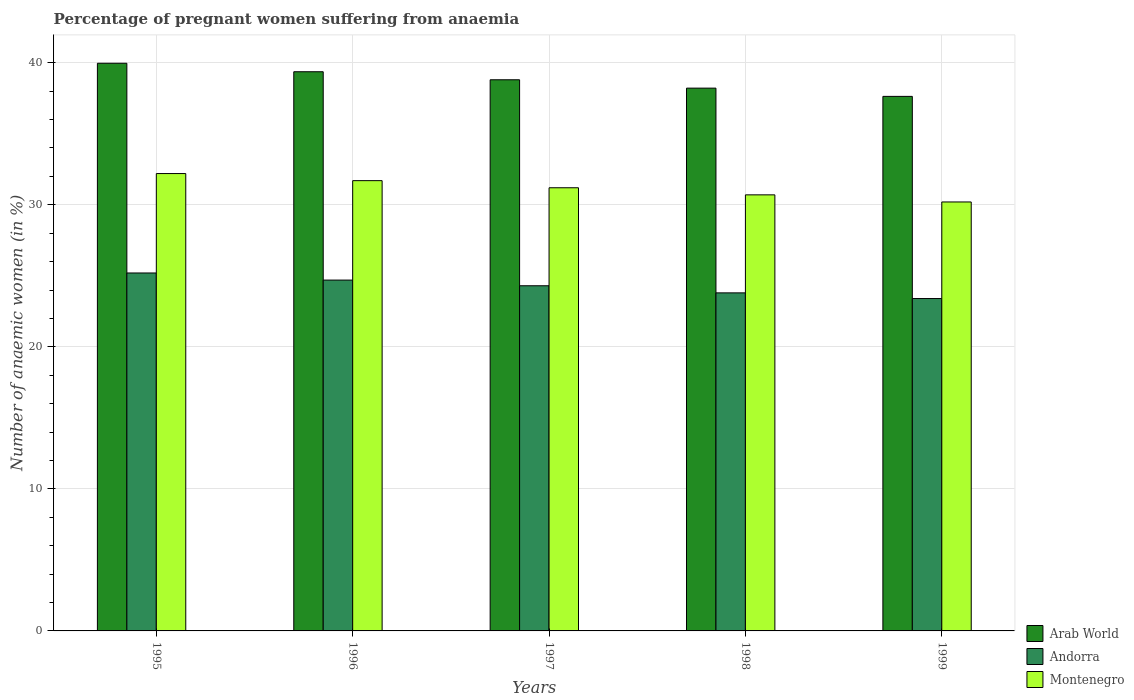How many different coloured bars are there?
Your response must be concise. 3. How many bars are there on the 4th tick from the left?
Your answer should be very brief. 3. What is the label of the 5th group of bars from the left?
Your response must be concise. 1999. In how many cases, is the number of bars for a given year not equal to the number of legend labels?
Your answer should be very brief. 0. What is the number of anaemic women in Andorra in 1998?
Your answer should be very brief. 23.8. Across all years, what is the maximum number of anaemic women in Andorra?
Offer a terse response. 25.2. Across all years, what is the minimum number of anaemic women in Arab World?
Give a very brief answer. 37.63. In which year was the number of anaemic women in Arab World minimum?
Offer a terse response. 1999. What is the total number of anaemic women in Montenegro in the graph?
Your answer should be compact. 156. What is the difference between the number of anaemic women in Arab World in 1996 and that in 1997?
Offer a very short reply. 0.57. What is the difference between the number of anaemic women in Andorra in 1998 and the number of anaemic women in Montenegro in 1999?
Give a very brief answer. -6.4. What is the average number of anaemic women in Andorra per year?
Keep it short and to the point. 24.28. In the year 1996, what is the difference between the number of anaemic women in Arab World and number of anaemic women in Andorra?
Your answer should be very brief. 14.67. What is the ratio of the number of anaemic women in Andorra in 1997 to that in 1999?
Your response must be concise. 1.04. What is the difference between the highest and the second highest number of anaemic women in Arab World?
Your response must be concise. 0.6. What is the difference between the highest and the lowest number of anaemic women in Arab World?
Offer a very short reply. 2.33. In how many years, is the number of anaemic women in Montenegro greater than the average number of anaemic women in Montenegro taken over all years?
Provide a short and direct response. 2. Is the sum of the number of anaemic women in Andorra in 1997 and 1998 greater than the maximum number of anaemic women in Arab World across all years?
Give a very brief answer. Yes. What does the 2nd bar from the left in 1997 represents?
Provide a short and direct response. Andorra. What does the 2nd bar from the right in 1998 represents?
Ensure brevity in your answer.  Andorra. Is it the case that in every year, the sum of the number of anaemic women in Andorra and number of anaemic women in Arab World is greater than the number of anaemic women in Montenegro?
Ensure brevity in your answer.  Yes. How many bars are there?
Offer a very short reply. 15. Are all the bars in the graph horizontal?
Provide a succinct answer. No. How many years are there in the graph?
Offer a terse response. 5. What is the difference between two consecutive major ticks on the Y-axis?
Keep it short and to the point. 10. Does the graph contain any zero values?
Your answer should be compact. No. Where does the legend appear in the graph?
Offer a very short reply. Bottom right. How many legend labels are there?
Provide a short and direct response. 3. How are the legend labels stacked?
Your answer should be very brief. Vertical. What is the title of the graph?
Your answer should be compact. Percentage of pregnant women suffering from anaemia. Does "Samoa" appear as one of the legend labels in the graph?
Keep it short and to the point. No. What is the label or title of the X-axis?
Make the answer very short. Years. What is the label or title of the Y-axis?
Make the answer very short. Number of anaemic women (in %). What is the Number of anaemic women (in %) of Arab World in 1995?
Give a very brief answer. 39.96. What is the Number of anaemic women (in %) of Andorra in 1995?
Your answer should be very brief. 25.2. What is the Number of anaemic women (in %) in Montenegro in 1995?
Ensure brevity in your answer.  32.2. What is the Number of anaemic women (in %) of Arab World in 1996?
Your response must be concise. 39.37. What is the Number of anaemic women (in %) of Andorra in 1996?
Keep it short and to the point. 24.7. What is the Number of anaemic women (in %) of Montenegro in 1996?
Offer a very short reply. 31.7. What is the Number of anaemic women (in %) of Arab World in 1997?
Ensure brevity in your answer.  38.8. What is the Number of anaemic women (in %) in Andorra in 1997?
Offer a very short reply. 24.3. What is the Number of anaemic women (in %) in Montenegro in 1997?
Give a very brief answer. 31.2. What is the Number of anaemic women (in %) in Arab World in 1998?
Your answer should be compact. 38.21. What is the Number of anaemic women (in %) in Andorra in 1998?
Your answer should be very brief. 23.8. What is the Number of anaemic women (in %) of Montenegro in 1998?
Offer a terse response. 30.7. What is the Number of anaemic women (in %) of Arab World in 1999?
Offer a very short reply. 37.63. What is the Number of anaemic women (in %) in Andorra in 1999?
Ensure brevity in your answer.  23.4. What is the Number of anaemic women (in %) in Montenegro in 1999?
Give a very brief answer. 30.2. Across all years, what is the maximum Number of anaemic women (in %) of Arab World?
Make the answer very short. 39.96. Across all years, what is the maximum Number of anaemic women (in %) in Andorra?
Provide a succinct answer. 25.2. Across all years, what is the maximum Number of anaemic women (in %) in Montenegro?
Offer a terse response. 32.2. Across all years, what is the minimum Number of anaemic women (in %) in Arab World?
Provide a short and direct response. 37.63. Across all years, what is the minimum Number of anaemic women (in %) in Andorra?
Keep it short and to the point. 23.4. Across all years, what is the minimum Number of anaemic women (in %) in Montenegro?
Keep it short and to the point. 30.2. What is the total Number of anaemic women (in %) of Arab World in the graph?
Provide a short and direct response. 193.98. What is the total Number of anaemic women (in %) in Andorra in the graph?
Your answer should be very brief. 121.4. What is the total Number of anaemic women (in %) in Montenegro in the graph?
Your response must be concise. 156. What is the difference between the Number of anaemic women (in %) of Arab World in 1995 and that in 1996?
Your answer should be compact. 0.6. What is the difference between the Number of anaemic women (in %) of Arab World in 1995 and that in 1997?
Provide a succinct answer. 1.16. What is the difference between the Number of anaemic women (in %) in Montenegro in 1995 and that in 1997?
Keep it short and to the point. 1. What is the difference between the Number of anaemic women (in %) in Arab World in 1995 and that in 1998?
Make the answer very short. 1.75. What is the difference between the Number of anaemic women (in %) in Andorra in 1995 and that in 1998?
Provide a succinct answer. 1.4. What is the difference between the Number of anaemic women (in %) of Arab World in 1995 and that in 1999?
Offer a very short reply. 2.33. What is the difference between the Number of anaemic women (in %) in Andorra in 1995 and that in 1999?
Give a very brief answer. 1.8. What is the difference between the Number of anaemic women (in %) of Montenegro in 1995 and that in 1999?
Give a very brief answer. 2. What is the difference between the Number of anaemic women (in %) in Arab World in 1996 and that in 1997?
Your answer should be very brief. 0.57. What is the difference between the Number of anaemic women (in %) of Arab World in 1996 and that in 1998?
Offer a very short reply. 1.15. What is the difference between the Number of anaemic women (in %) in Andorra in 1996 and that in 1998?
Keep it short and to the point. 0.9. What is the difference between the Number of anaemic women (in %) in Montenegro in 1996 and that in 1998?
Provide a succinct answer. 1. What is the difference between the Number of anaemic women (in %) in Arab World in 1996 and that in 1999?
Provide a short and direct response. 1.74. What is the difference between the Number of anaemic women (in %) of Andorra in 1996 and that in 1999?
Provide a short and direct response. 1.3. What is the difference between the Number of anaemic women (in %) of Montenegro in 1996 and that in 1999?
Offer a very short reply. 1.5. What is the difference between the Number of anaemic women (in %) in Arab World in 1997 and that in 1998?
Give a very brief answer. 0.59. What is the difference between the Number of anaemic women (in %) in Andorra in 1997 and that in 1998?
Offer a very short reply. 0.5. What is the difference between the Number of anaemic women (in %) in Montenegro in 1997 and that in 1998?
Provide a short and direct response. 0.5. What is the difference between the Number of anaemic women (in %) in Arab World in 1997 and that in 1999?
Ensure brevity in your answer.  1.17. What is the difference between the Number of anaemic women (in %) of Montenegro in 1997 and that in 1999?
Ensure brevity in your answer.  1. What is the difference between the Number of anaemic women (in %) in Arab World in 1998 and that in 1999?
Provide a short and direct response. 0.58. What is the difference between the Number of anaemic women (in %) of Arab World in 1995 and the Number of anaemic women (in %) of Andorra in 1996?
Ensure brevity in your answer.  15.26. What is the difference between the Number of anaemic women (in %) of Arab World in 1995 and the Number of anaemic women (in %) of Montenegro in 1996?
Provide a short and direct response. 8.26. What is the difference between the Number of anaemic women (in %) of Arab World in 1995 and the Number of anaemic women (in %) of Andorra in 1997?
Your answer should be very brief. 15.66. What is the difference between the Number of anaemic women (in %) in Arab World in 1995 and the Number of anaemic women (in %) in Montenegro in 1997?
Make the answer very short. 8.76. What is the difference between the Number of anaemic women (in %) in Arab World in 1995 and the Number of anaemic women (in %) in Andorra in 1998?
Provide a succinct answer. 16.16. What is the difference between the Number of anaemic women (in %) in Arab World in 1995 and the Number of anaemic women (in %) in Montenegro in 1998?
Your response must be concise. 9.26. What is the difference between the Number of anaemic women (in %) of Andorra in 1995 and the Number of anaemic women (in %) of Montenegro in 1998?
Provide a succinct answer. -5.5. What is the difference between the Number of anaemic women (in %) in Arab World in 1995 and the Number of anaemic women (in %) in Andorra in 1999?
Ensure brevity in your answer.  16.56. What is the difference between the Number of anaemic women (in %) in Arab World in 1995 and the Number of anaemic women (in %) in Montenegro in 1999?
Offer a terse response. 9.76. What is the difference between the Number of anaemic women (in %) of Arab World in 1996 and the Number of anaemic women (in %) of Andorra in 1997?
Provide a succinct answer. 15.07. What is the difference between the Number of anaemic women (in %) in Arab World in 1996 and the Number of anaemic women (in %) in Montenegro in 1997?
Your answer should be compact. 8.17. What is the difference between the Number of anaemic women (in %) in Arab World in 1996 and the Number of anaemic women (in %) in Andorra in 1998?
Provide a succinct answer. 15.57. What is the difference between the Number of anaemic women (in %) in Arab World in 1996 and the Number of anaemic women (in %) in Montenegro in 1998?
Your response must be concise. 8.67. What is the difference between the Number of anaemic women (in %) in Arab World in 1996 and the Number of anaemic women (in %) in Andorra in 1999?
Provide a short and direct response. 15.97. What is the difference between the Number of anaemic women (in %) in Arab World in 1996 and the Number of anaemic women (in %) in Montenegro in 1999?
Your answer should be very brief. 9.17. What is the difference between the Number of anaemic women (in %) in Andorra in 1996 and the Number of anaemic women (in %) in Montenegro in 1999?
Offer a terse response. -5.5. What is the difference between the Number of anaemic women (in %) of Arab World in 1997 and the Number of anaemic women (in %) of Andorra in 1998?
Keep it short and to the point. 15. What is the difference between the Number of anaemic women (in %) in Arab World in 1997 and the Number of anaemic women (in %) in Montenegro in 1998?
Offer a very short reply. 8.1. What is the difference between the Number of anaemic women (in %) of Andorra in 1997 and the Number of anaemic women (in %) of Montenegro in 1998?
Provide a succinct answer. -6.4. What is the difference between the Number of anaemic women (in %) of Arab World in 1997 and the Number of anaemic women (in %) of Andorra in 1999?
Provide a succinct answer. 15.4. What is the difference between the Number of anaemic women (in %) in Arab World in 1997 and the Number of anaemic women (in %) in Montenegro in 1999?
Offer a very short reply. 8.6. What is the difference between the Number of anaemic women (in %) in Arab World in 1998 and the Number of anaemic women (in %) in Andorra in 1999?
Keep it short and to the point. 14.81. What is the difference between the Number of anaemic women (in %) of Arab World in 1998 and the Number of anaemic women (in %) of Montenegro in 1999?
Keep it short and to the point. 8.01. What is the difference between the Number of anaemic women (in %) in Andorra in 1998 and the Number of anaemic women (in %) in Montenegro in 1999?
Make the answer very short. -6.4. What is the average Number of anaemic women (in %) of Arab World per year?
Offer a very short reply. 38.8. What is the average Number of anaemic women (in %) in Andorra per year?
Offer a terse response. 24.28. What is the average Number of anaemic women (in %) in Montenegro per year?
Offer a terse response. 31.2. In the year 1995, what is the difference between the Number of anaemic women (in %) of Arab World and Number of anaemic women (in %) of Andorra?
Offer a very short reply. 14.76. In the year 1995, what is the difference between the Number of anaemic women (in %) of Arab World and Number of anaemic women (in %) of Montenegro?
Your answer should be very brief. 7.76. In the year 1996, what is the difference between the Number of anaemic women (in %) in Arab World and Number of anaemic women (in %) in Andorra?
Provide a short and direct response. 14.67. In the year 1996, what is the difference between the Number of anaemic women (in %) of Arab World and Number of anaemic women (in %) of Montenegro?
Keep it short and to the point. 7.67. In the year 1997, what is the difference between the Number of anaemic women (in %) of Arab World and Number of anaemic women (in %) of Andorra?
Provide a short and direct response. 14.5. In the year 1997, what is the difference between the Number of anaemic women (in %) in Arab World and Number of anaemic women (in %) in Montenegro?
Provide a succinct answer. 7.6. In the year 1997, what is the difference between the Number of anaemic women (in %) in Andorra and Number of anaemic women (in %) in Montenegro?
Provide a short and direct response. -6.9. In the year 1998, what is the difference between the Number of anaemic women (in %) in Arab World and Number of anaemic women (in %) in Andorra?
Your answer should be compact. 14.41. In the year 1998, what is the difference between the Number of anaemic women (in %) in Arab World and Number of anaemic women (in %) in Montenegro?
Give a very brief answer. 7.51. In the year 1999, what is the difference between the Number of anaemic women (in %) in Arab World and Number of anaemic women (in %) in Andorra?
Ensure brevity in your answer.  14.23. In the year 1999, what is the difference between the Number of anaemic women (in %) of Arab World and Number of anaemic women (in %) of Montenegro?
Your answer should be very brief. 7.43. What is the ratio of the Number of anaemic women (in %) of Arab World in 1995 to that in 1996?
Make the answer very short. 1.02. What is the ratio of the Number of anaemic women (in %) in Andorra in 1995 to that in 1996?
Keep it short and to the point. 1.02. What is the ratio of the Number of anaemic women (in %) of Montenegro in 1995 to that in 1996?
Keep it short and to the point. 1.02. What is the ratio of the Number of anaemic women (in %) in Andorra in 1995 to that in 1997?
Keep it short and to the point. 1.04. What is the ratio of the Number of anaemic women (in %) of Montenegro in 1995 to that in 1997?
Your answer should be compact. 1.03. What is the ratio of the Number of anaemic women (in %) in Arab World in 1995 to that in 1998?
Offer a very short reply. 1.05. What is the ratio of the Number of anaemic women (in %) in Andorra in 1995 to that in 1998?
Your answer should be very brief. 1.06. What is the ratio of the Number of anaemic women (in %) of Montenegro in 1995 to that in 1998?
Your response must be concise. 1.05. What is the ratio of the Number of anaemic women (in %) of Arab World in 1995 to that in 1999?
Provide a succinct answer. 1.06. What is the ratio of the Number of anaemic women (in %) in Montenegro in 1995 to that in 1999?
Ensure brevity in your answer.  1.07. What is the ratio of the Number of anaemic women (in %) of Arab World in 1996 to that in 1997?
Ensure brevity in your answer.  1.01. What is the ratio of the Number of anaemic women (in %) in Andorra in 1996 to that in 1997?
Give a very brief answer. 1.02. What is the ratio of the Number of anaemic women (in %) in Montenegro in 1996 to that in 1997?
Ensure brevity in your answer.  1.02. What is the ratio of the Number of anaemic women (in %) in Arab World in 1996 to that in 1998?
Offer a very short reply. 1.03. What is the ratio of the Number of anaemic women (in %) in Andorra in 1996 to that in 1998?
Give a very brief answer. 1.04. What is the ratio of the Number of anaemic women (in %) in Montenegro in 1996 to that in 1998?
Provide a succinct answer. 1.03. What is the ratio of the Number of anaemic women (in %) of Arab World in 1996 to that in 1999?
Offer a terse response. 1.05. What is the ratio of the Number of anaemic women (in %) in Andorra in 1996 to that in 1999?
Give a very brief answer. 1.06. What is the ratio of the Number of anaemic women (in %) of Montenegro in 1996 to that in 1999?
Ensure brevity in your answer.  1.05. What is the ratio of the Number of anaemic women (in %) in Arab World in 1997 to that in 1998?
Offer a terse response. 1.02. What is the ratio of the Number of anaemic women (in %) of Montenegro in 1997 to that in 1998?
Provide a short and direct response. 1.02. What is the ratio of the Number of anaemic women (in %) in Arab World in 1997 to that in 1999?
Your response must be concise. 1.03. What is the ratio of the Number of anaemic women (in %) in Andorra in 1997 to that in 1999?
Provide a short and direct response. 1.04. What is the ratio of the Number of anaemic women (in %) in Montenegro in 1997 to that in 1999?
Offer a terse response. 1.03. What is the ratio of the Number of anaemic women (in %) in Arab World in 1998 to that in 1999?
Offer a very short reply. 1.02. What is the ratio of the Number of anaemic women (in %) in Andorra in 1998 to that in 1999?
Give a very brief answer. 1.02. What is the ratio of the Number of anaemic women (in %) in Montenegro in 1998 to that in 1999?
Your answer should be very brief. 1.02. What is the difference between the highest and the second highest Number of anaemic women (in %) of Arab World?
Give a very brief answer. 0.6. What is the difference between the highest and the second highest Number of anaemic women (in %) in Andorra?
Offer a very short reply. 0.5. What is the difference between the highest and the second highest Number of anaemic women (in %) of Montenegro?
Offer a very short reply. 0.5. What is the difference between the highest and the lowest Number of anaemic women (in %) in Arab World?
Keep it short and to the point. 2.33. What is the difference between the highest and the lowest Number of anaemic women (in %) in Montenegro?
Your response must be concise. 2. 